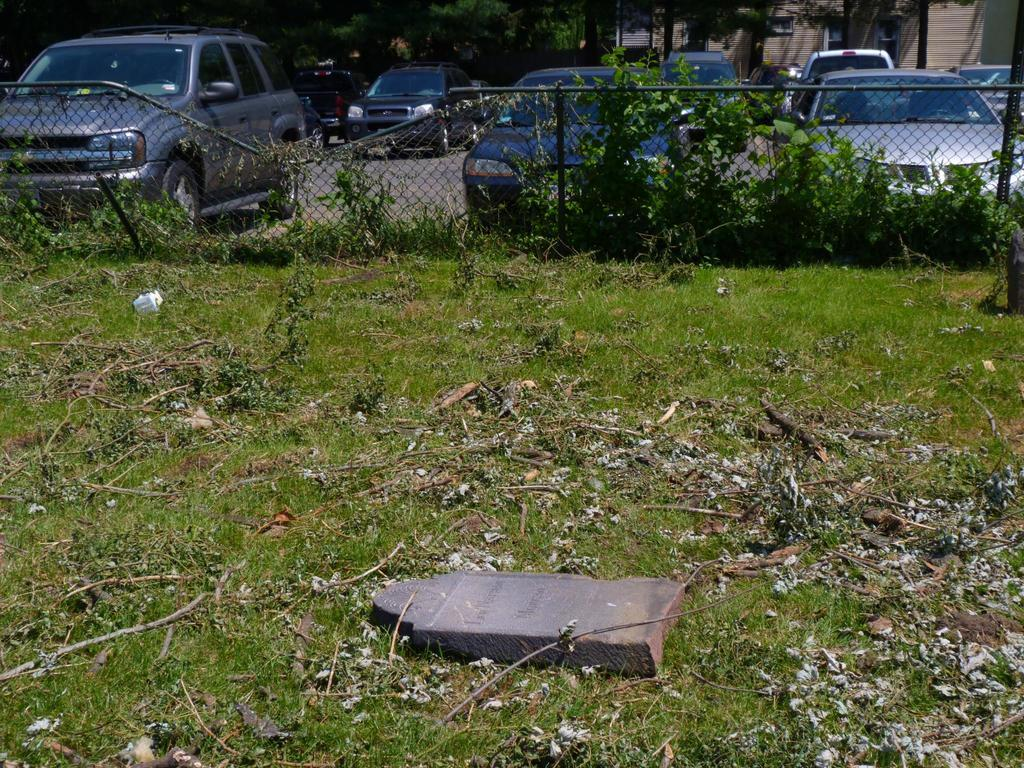What type of surface is on the ground in the image? There is grass and dust on the ground in the image. What can be seen growing near the fence? There are plants at the fence in the image. What is visible in the background of the image? Vehicles on the road, trees, windows, and a building can be seen in the background of the image. What type of discovery was made using the rail and pail in the image? There is no rail or pail present in the image, so no such discovery can be made. 